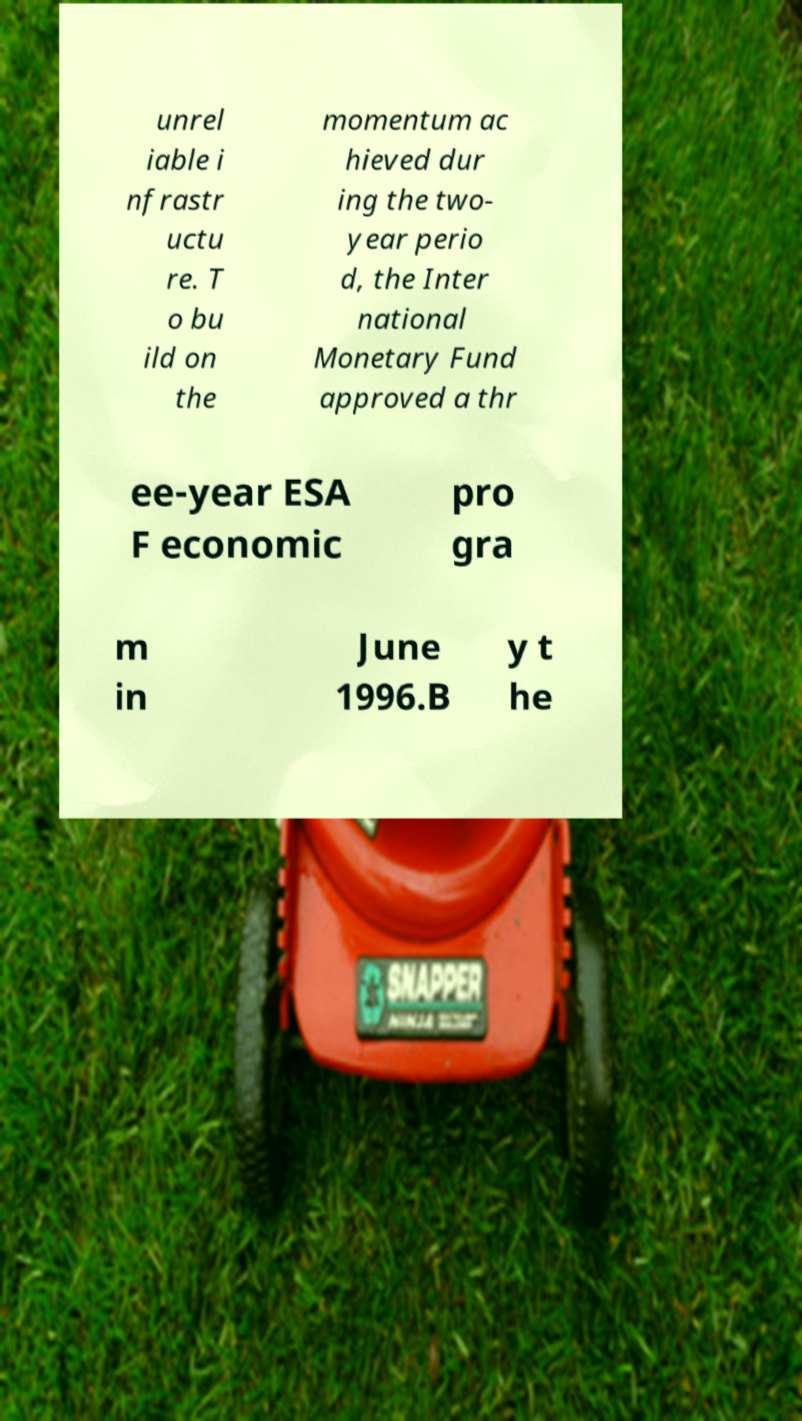I need the written content from this picture converted into text. Can you do that? unrel iable i nfrastr uctu re. T o bu ild on the momentum ac hieved dur ing the two- year perio d, the Inter national Monetary Fund approved a thr ee-year ESA F economic pro gra m in June 1996.B y t he 